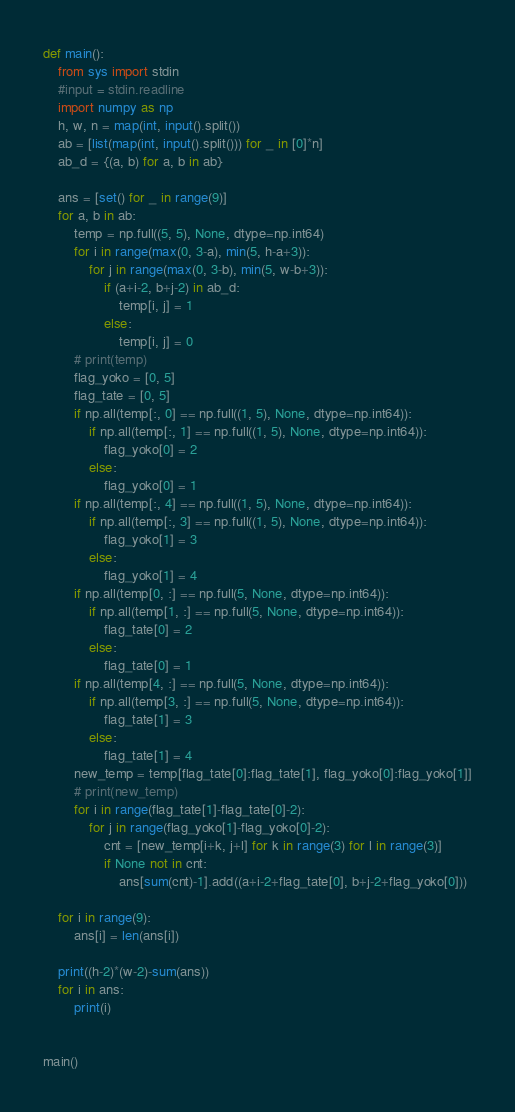<code> <loc_0><loc_0><loc_500><loc_500><_Python_>def main():
    from sys import stdin
    #input = stdin.readline
    import numpy as np
    h, w, n = map(int, input().split())
    ab = [list(map(int, input().split())) for _ in [0]*n]
    ab_d = {(a, b) for a, b in ab}

    ans = [set() for _ in range(9)]
    for a, b in ab:
        temp = np.full((5, 5), None, dtype=np.int64)
        for i in range(max(0, 3-a), min(5, h-a+3)):
            for j in range(max(0, 3-b), min(5, w-b+3)):
                if (a+i-2, b+j-2) in ab_d:
                    temp[i, j] = 1
                else:
                    temp[i, j] = 0
        # print(temp)
        flag_yoko = [0, 5]
        flag_tate = [0, 5]
        if np.all(temp[:, 0] == np.full((1, 5), None, dtype=np.int64)):
            if np.all(temp[:, 1] == np.full((1, 5), None, dtype=np.int64)):
                flag_yoko[0] = 2
            else:
                flag_yoko[0] = 1
        if np.all(temp[:, 4] == np.full((1, 5), None, dtype=np.int64)):
            if np.all(temp[:, 3] == np.full((1, 5), None, dtype=np.int64)):
                flag_yoko[1] = 3
            else:
                flag_yoko[1] = 4
        if np.all(temp[0, :] == np.full(5, None, dtype=np.int64)):
            if np.all(temp[1, :] == np.full(5, None, dtype=np.int64)):
                flag_tate[0] = 2
            else:
                flag_tate[0] = 1
        if np.all(temp[4, :] == np.full(5, None, dtype=np.int64)):
            if np.all(temp[3, :] == np.full(5, None, dtype=np.int64)):
                flag_tate[1] = 3
            else:
                flag_tate[1] = 4
        new_temp = temp[flag_tate[0]:flag_tate[1], flag_yoko[0]:flag_yoko[1]]
        # print(new_temp)
        for i in range(flag_tate[1]-flag_tate[0]-2):
            for j in range(flag_yoko[1]-flag_yoko[0]-2):
                cnt = [new_temp[i+k, j+l] for k in range(3) for l in range(3)]
                if None not in cnt:
                    ans[sum(cnt)-1].add((a+i-2+flag_tate[0], b+j-2+flag_yoko[0]))

    for i in range(9):
        ans[i] = len(ans[i])

    print((h-2)*(w-2)-sum(ans))
    for i in ans:
        print(i)


main()
</code> 